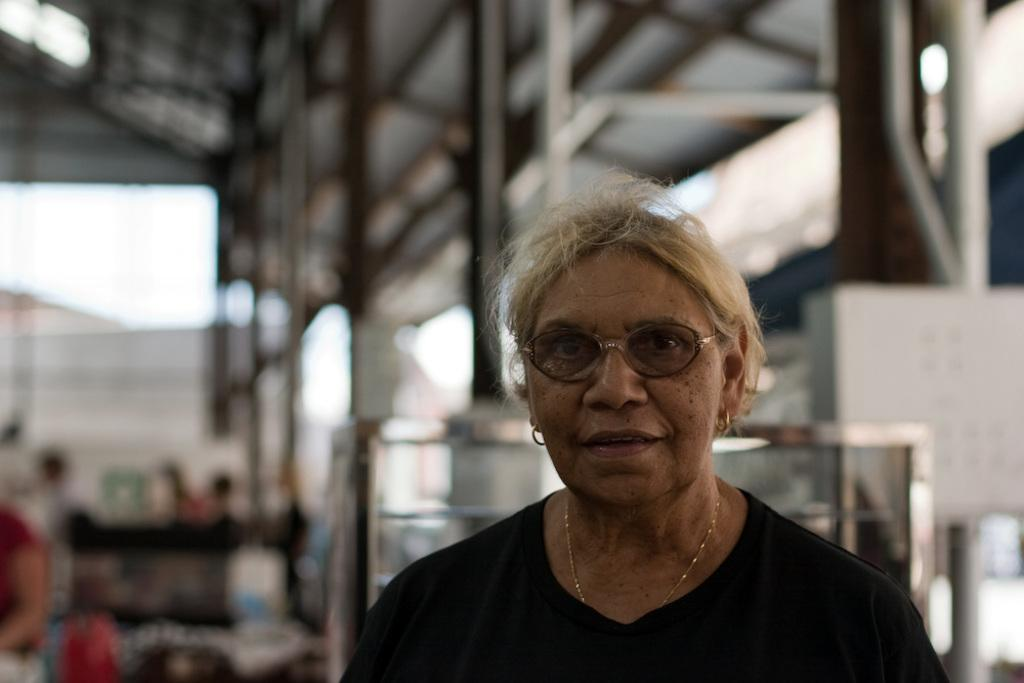Who is the main subject in the foreground of the image? There is a woman in the foreground of the image. What is the woman wearing in the image? The woman is wearing a black T-shirt. Can you describe the background of the image? The background of the image is blurred. What is the rate of the letters falling from the sky in the image? There are no letters falling from the sky in the image. What type of structure is visible in the background of the image? There is no structure visible in the background of the image; it is blurred. 